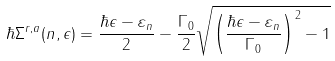Convert formula to latex. <formula><loc_0><loc_0><loc_500><loc_500>\hbar { \Sigma } ^ { r , a } ( n , \epsilon ) = \frac { \hbar { \epsilon } - \varepsilon _ { n } } { 2 } - \frac { \Gamma _ { 0 } } { 2 } \sqrt { \left ( \frac { \hbar { \epsilon } - \varepsilon _ { n } } { \Gamma _ { 0 } } \right ) ^ { 2 } - 1 }</formula> 